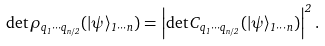<formula> <loc_0><loc_0><loc_500><loc_500>\det \rho _ { q _ { 1 } \cdots q _ { n / 2 } } ( | \psi \rangle _ { 1 \cdots n } ) = \left | \det C _ { q _ { 1 } \cdots q _ { n / 2 } } ( | \psi \rangle _ { 1 \cdots n } ) \right | ^ { 2 } .</formula> 